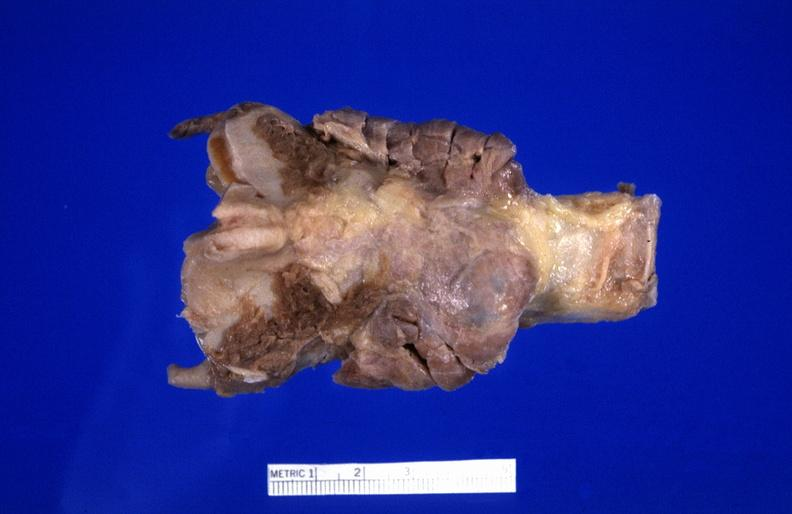where does this belong to?
Answer the question using a single word or phrase. Endocrine system 